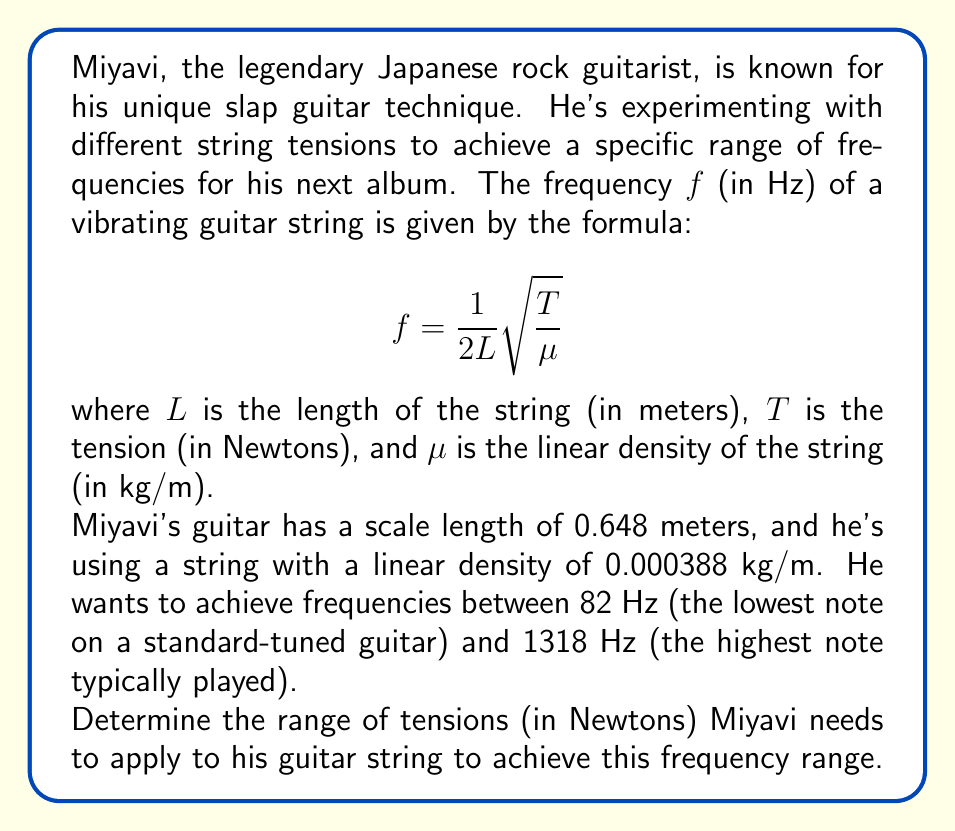Can you solve this math problem? Let's approach this step-by-step:

1) We start with the given formula:

   $$f = \frac{1}{2L}\sqrt{\frac{T}{\mu}}$$

2) We're given:
   - $L = 0.648$ m
   - $\mu = 0.000388$ kg/m
   - $f_{min} = 82$ Hz
   - $f_{max} = 1318$ Hz

3) We need to solve for $T$. Let's rearrange the formula:

   $$T = 4L^2\mu f^2$$

4) Now, let's substitute the known values:

   $$T = 4(0.648)^2(0.000388)f^2 = 0.000652f^2$$

5) For the minimum frequency:

   $$T_{min} = 0.000652(82)^2 = 4.38 \text{ N}$$

6) For the maximum frequency:

   $$T_{max} = 0.000652(1318)^2 = 1131.76 \text{ N}$$

7) Therefore, the range of tensions is represented by the inequality:

   $$4.38 \leq T \leq 1131.76$$
Answer: The range of tensions Miyavi needs to apply to his guitar string is:

$$4.38 \text{ N} \leq T \leq 1131.76 \text{ N}$$ 